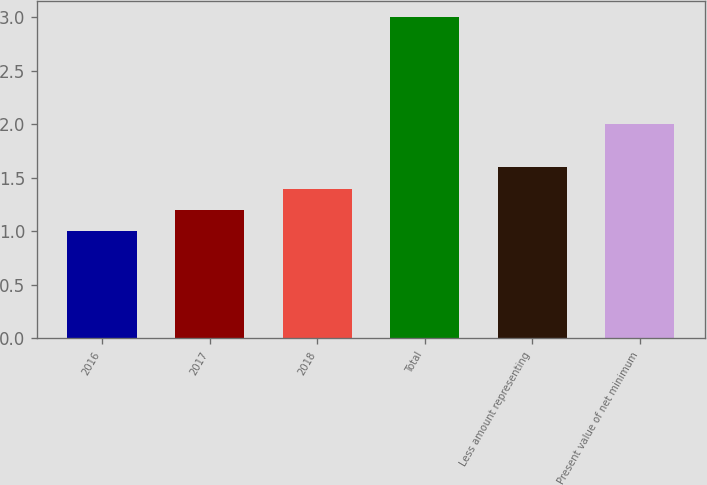<chart> <loc_0><loc_0><loc_500><loc_500><bar_chart><fcel>2016<fcel>2017<fcel>2018<fcel>Total<fcel>Less amount representing<fcel>Present value of net minimum<nl><fcel>1<fcel>1.2<fcel>1.4<fcel>3<fcel>1.6<fcel>2<nl></chart> 